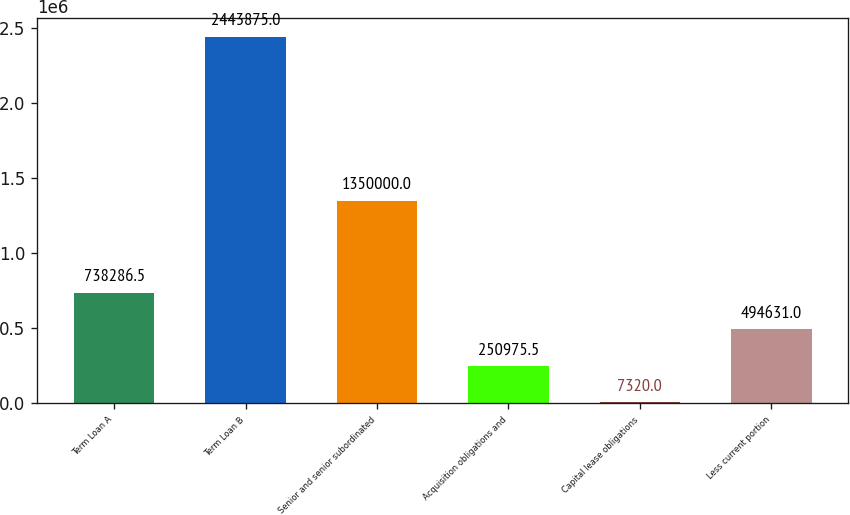Convert chart to OTSL. <chart><loc_0><loc_0><loc_500><loc_500><bar_chart><fcel>Term Loan A<fcel>Term Loan B<fcel>Senior and senior subordinated<fcel>Acquisition obligations and<fcel>Capital lease obligations<fcel>Less current portion<nl><fcel>738286<fcel>2.44388e+06<fcel>1.35e+06<fcel>250976<fcel>7320<fcel>494631<nl></chart> 